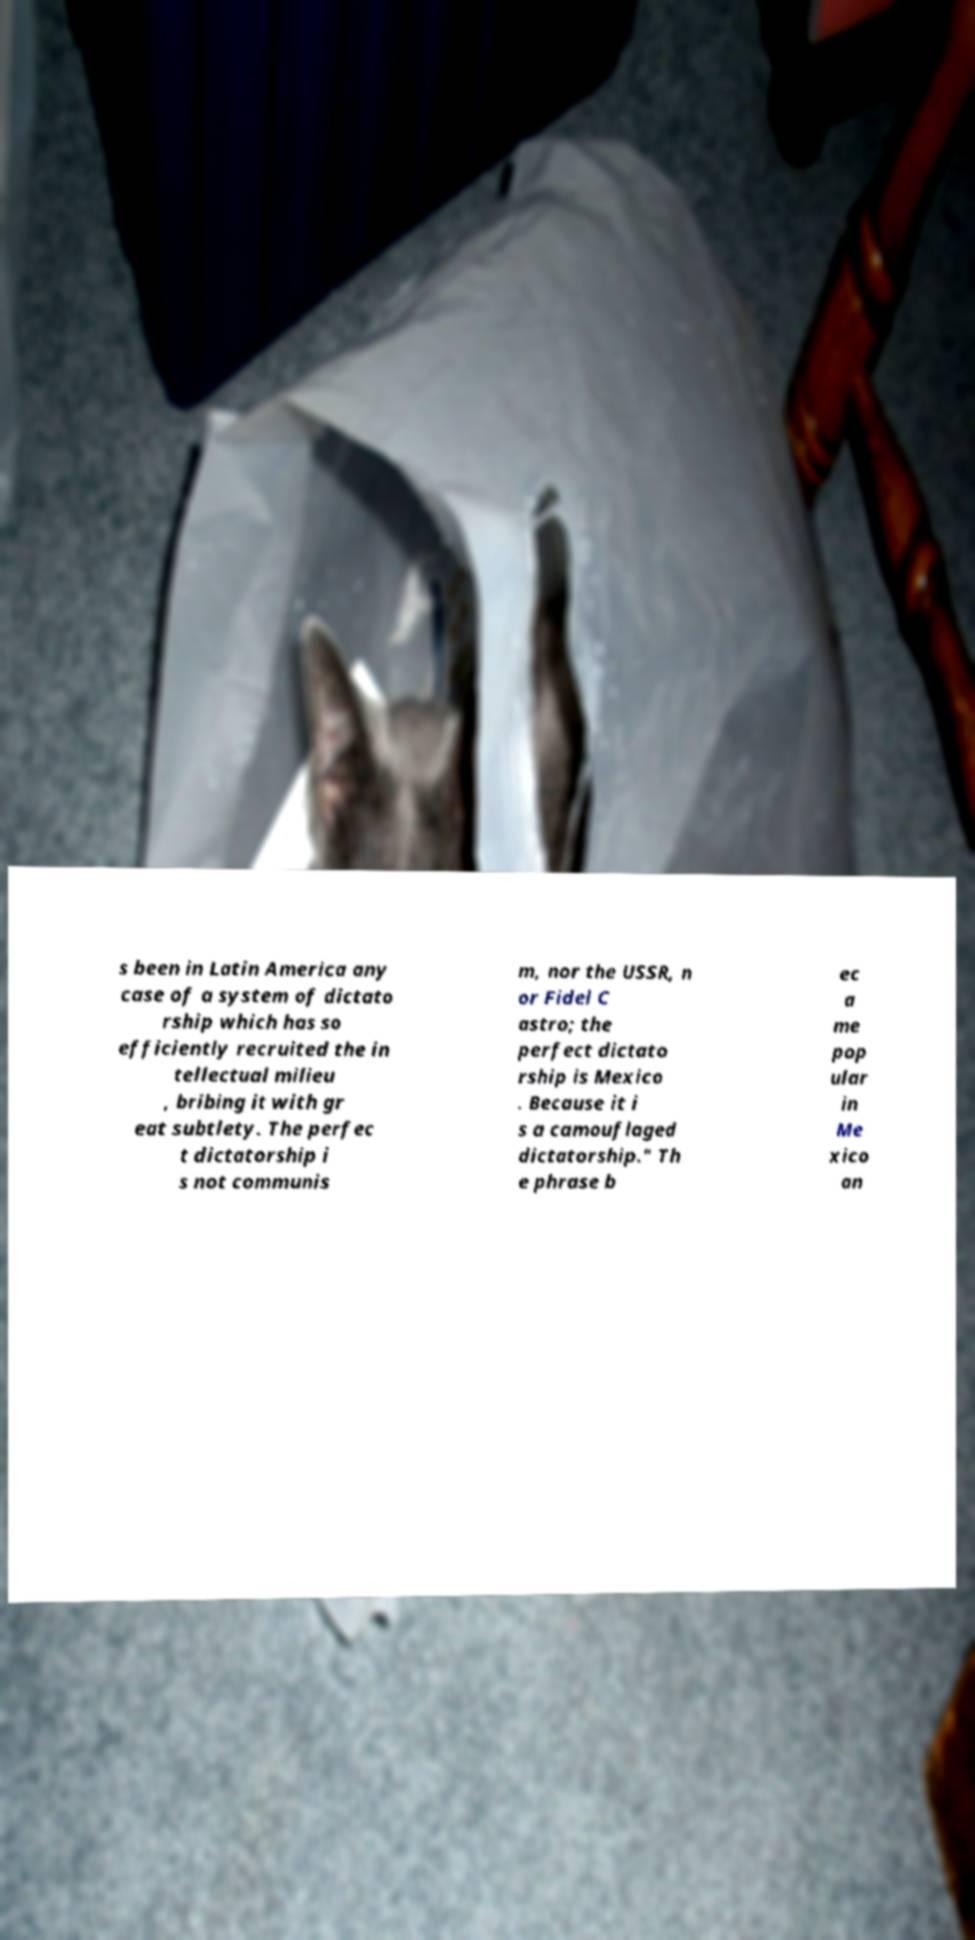Please read and relay the text visible in this image. What does it say? s been in Latin America any case of a system of dictato rship which has so efficiently recruited the in tellectual milieu , bribing it with gr eat subtlety. The perfec t dictatorship i s not communis m, nor the USSR, n or Fidel C astro; the perfect dictato rship is Mexico . Because it i s a camouflaged dictatorship." Th e phrase b ec a me pop ular in Me xico an 